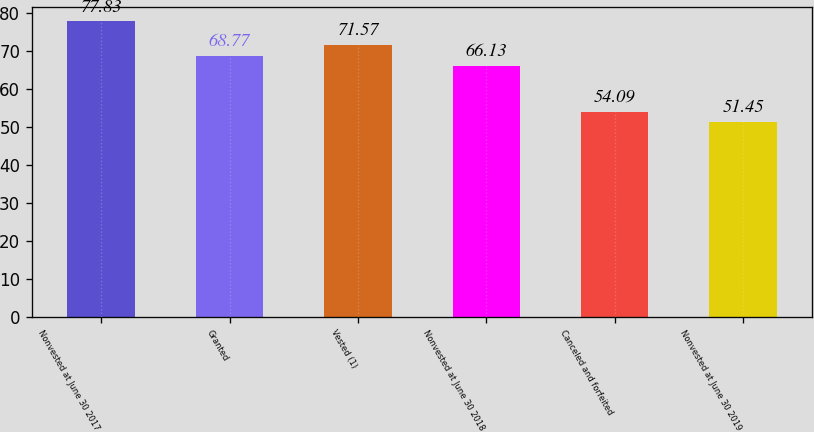Convert chart to OTSL. <chart><loc_0><loc_0><loc_500><loc_500><bar_chart><fcel>Nonvested at June 30 2017<fcel>Granted<fcel>Vested (1)<fcel>Nonvested at June 30 2018<fcel>Canceled and forfeited<fcel>Nonvested at June 30 2019<nl><fcel>77.83<fcel>68.77<fcel>71.57<fcel>66.13<fcel>54.09<fcel>51.45<nl></chart> 